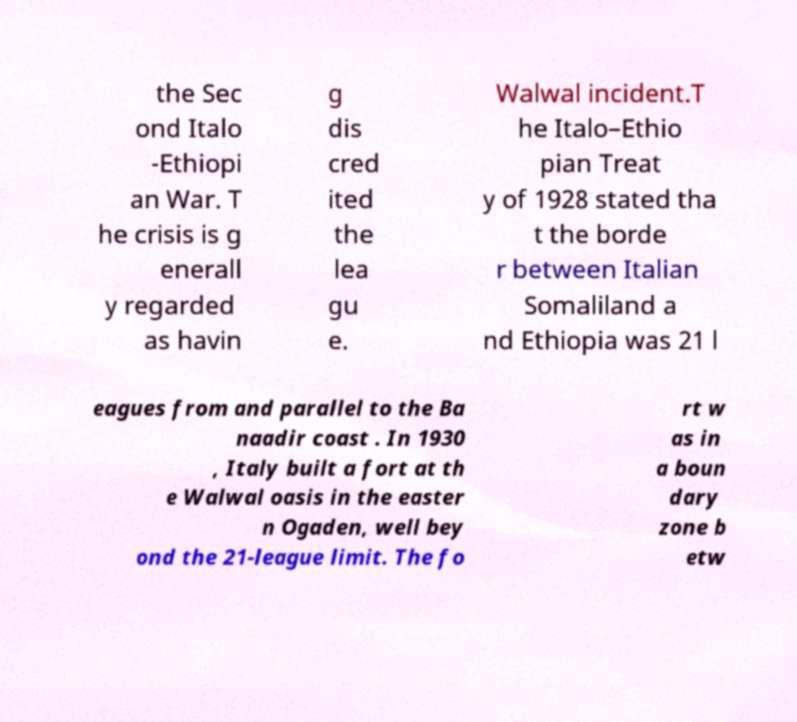Can you read and provide the text displayed in the image?This photo seems to have some interesting text. Can you extract and type it out for me? the Sec ond Italo -Ethiopi an War. T he crisis is g enerall y regarded as havin g dis cred ited the lea gu e. Walwal incident.T he Italo–Ethio pian Treat y of 1928 stated tha t the borde r between Italian Somaliland a nd Ethiopia was 21 l eagues from and parallel to the Ba naadir coast . In 1930 , Italy built a fort at th e Walwal oasis in the easter n Ogaden, well bey ond the 21-league limit. The fo rt w as in a boun dary zone b etw 